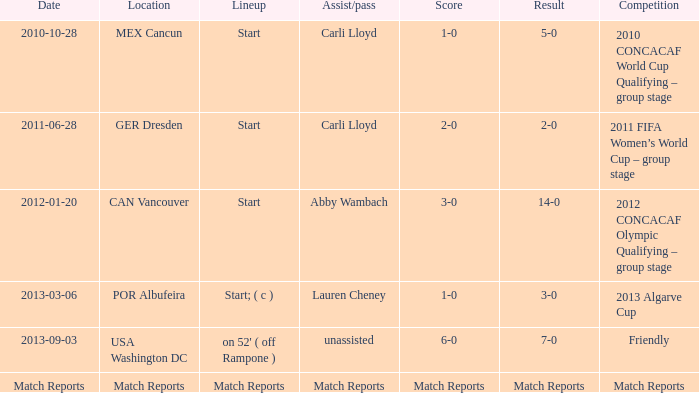Identify the consequence of the initial lineup, a carli lloyd assist/pass, and the 2011 fifa women's world cup – group phase contest? 2-0. 